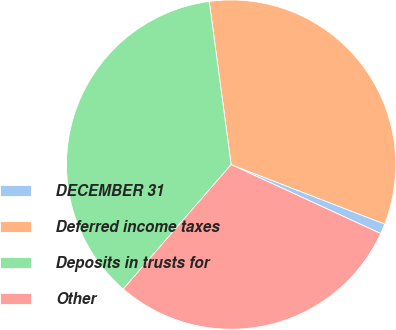Convert chart to OTSL. <chart><loc_0><loc_0><loc_500><loc_500><pie_chart><fcel>DECEMBER 31<fcel>Deferred income taxes<fcel>Deposits in trusts for<fcel>Other<nl><fcel>1.0%<fcel>33.0%<fcel>36.51%<fcel>29.49%<nl></chart> 